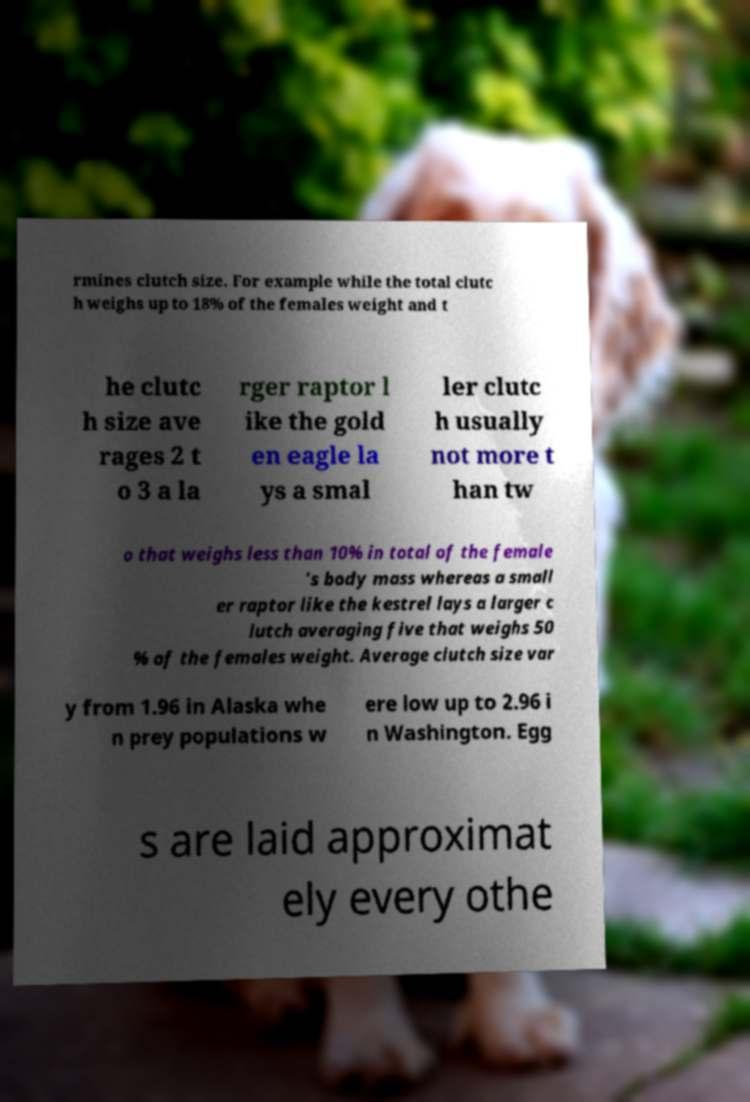Could you assist in decoding the text presented in this image and type it out clearly? rmines clutch size. For example while the total clutc h weighs up to 18% of the females weight and t he clutc h size ave rages 2 t o 3 a la rger raptor l ike the gold en eagle la ys a smal ler clutc h usually not more t han tw o that weighs less than 10% in total of the female ’s body mass whereas a small er raptor like the kestrel lays a larger c lutch averaging five that weighs 50 % of the females weight. Average clutch size var y from 1.96 in Alaska whe n prey populations w ere low up to 2.96 i n Washington. Egg s are laid approximat ely every othe 